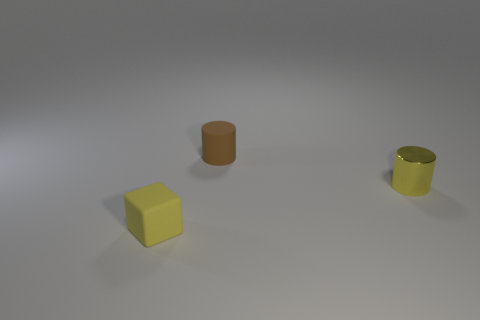What number of other tiny cylinders have the same material as the yellow cylinder? There does not appear to be any other tiny cylinders made of the same material as the yellow cylinder visible in this image. Objects in the image have different colors, and assuming material difference from color and texture, each cylinder seems to have a unique material. 